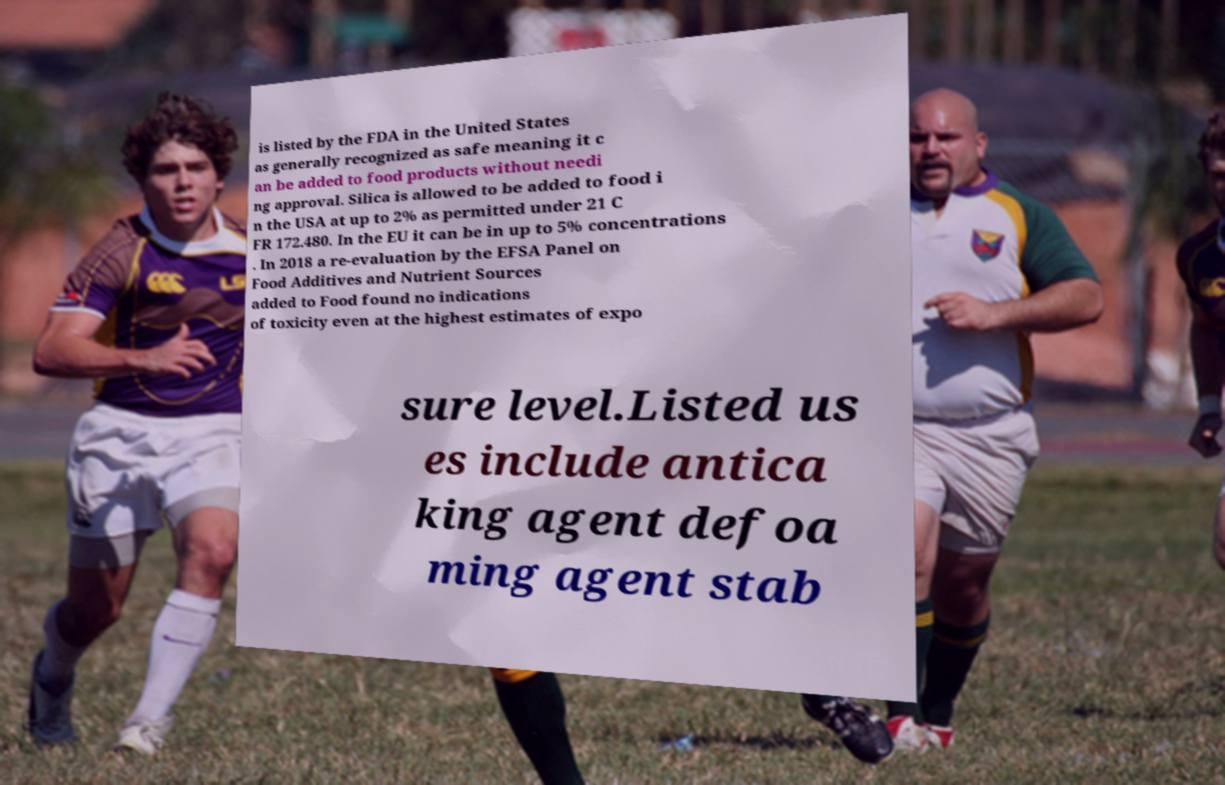Please read and relay the text visible in this image. What does it say? is listed by the FDA in the United States as generally recognized as safe meaning it c an be added to food products without needi ng approval. Silica is allowed to be added to food i n the USA at up to 2% as permitted under 21 C FR 172.480. In the EU it can be in up to 5% concentrations . In 2018 a re-evaluation by the EFSA Panel on Food Additives and Nutrient Sources added to Food found no indications of toxicity even at the highest estimates of expo sure level.Listed us es include antica king agent defoa ming agent stab 